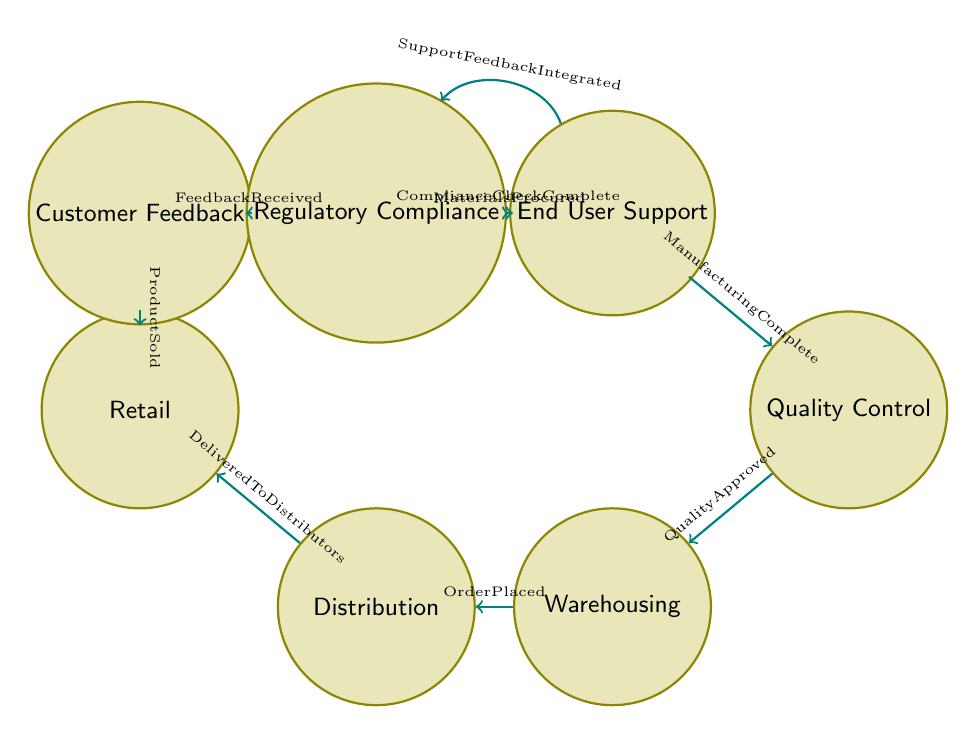What is the first state in the supply chain diagram? The first state identified in the diagram is "Raw Material Sourcing," which represents the initial stage of procurement for active ingredients and materials needed for pesticide production.
Answer: Raw Material Sourcing How many states are represented in the diagram? By counting the individual states listed in the diagram, we find there are nine distinct states that illustrate different aspects of the supply chain process.
Answer: Nine What condition leads from Manufacturing to Quality Control? The transition from Manufacturing to Quality Control occurs when the condition "ManufacturingComplete" is met, indicating the completion of the production process.
Answer: ManufacturingComplete Which state follows Warehousing? The state that follows Warehousing in the flow of the diagram is Distribution, signifying the transfer of products from a storage facility to various distributors and retailers.
Answer: Distribution What is the final state in the supply chain process depicted in the diagram? The final state reached in the process, following the completion of regulatory compliance checks, is End User Support, highlighting the company’s commitment to assisting customers after product purchase.
Answer: End User Support How does Customer Feedback relate to Regulatory Compliance? Customer Feedback transitions to Regulatory Compliance upon the condition "FeedbackReceived," indicating that user insights on product efficacy and safety are critical for maintaining compliance with regulations.
Answer: FeedbackReceived How many transitions are there in total in the diagram? By counting each arrow that connects the states, we can determine that there are eight transitions that illustrate the flow of the supply chain management process for pesticide products.
Answer: Eight What must occur after Quality Control before products can be warehoused? Before products can move to the Warehousing state after Quality Control, they must be "QualityApproved," demonstrating that they meet the necessary standards.
Answer: QualityApproved What is the condition required for the transition from Distribution to Retail? The transition from Distribution to Retail occurs when the condition "DeliveredToDistributors" is satisfied, indicating that products have successfully reached their intended distributors.
Answer: DeliveredToDistributors 